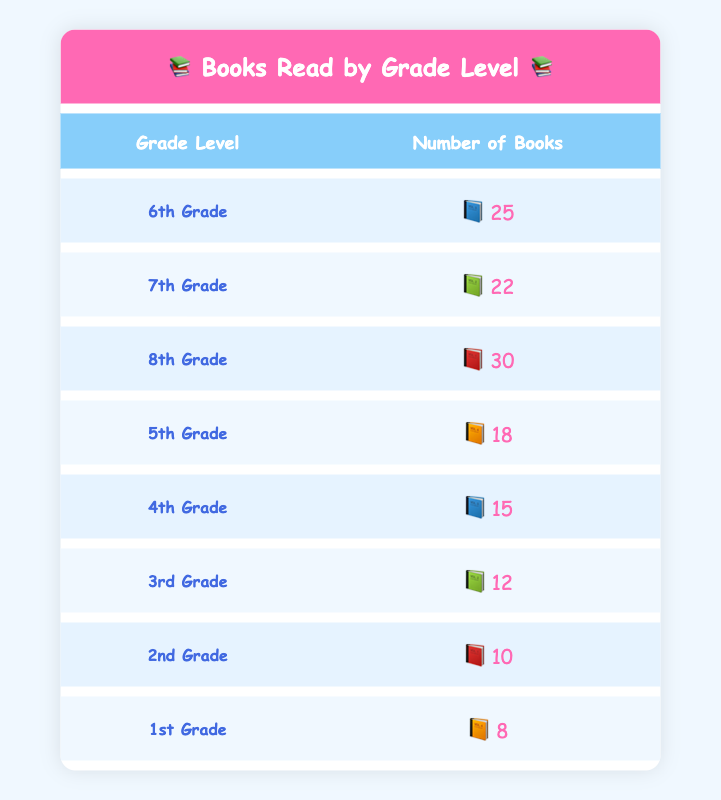What grade level read the most books? By examining the table, we can see that the highest number of books read corresponds to "8th Grade," which shows 30 books.
Answer: 8th Grade How many books did 5th Grade students read? The table directly indicates that "5th Grade" students read 18 books.
Answer: 18 What is the total number of books read by 6th Grade and 7th Grade combined? To find the total, we add the number of books read by 6th Grade (25) and 7th Grade (22). So, 25 + 22 = 47.
Answer: 47 Is it true that 2nd Grade read more books than 1st Grade? Looking at the table, 2nd Grade read 10 books, and 1st Grade read 8 books. Since 10 is more than 8, the statement is true.
Answer: Yes What is the average number of books read by all the grades? First, sum the number of books read across all grades: 25 + 22 + 30 + 18 + 15 + 12 + 10 + 8 = 140. There are 8 grade levels, so to find the average, we divide the total by 8. Therefore, 140 / 8 = 17.5.
Answer: 17.5 Which grade read the least number of books? From the table, "1st Grade" has the lowest number of books read, which is 8 books.
Answer: 1st Grade If we compare 4th Grade and 3rd Grade, which grade read more books? The table shows that 4th Grade read 15 books while 3rd Grade read 12 books. Since 15 is greater than 12, 4th Grade read more.
Answer: 4th Grade What is the difference in the number of books read between 6th Grade and 5th Grade? To find the difference, subtract the number of books read by 5th Grade (18) from the number read by 6th Grade (25). So, 25 - 18 = 7.
Answer: 7 